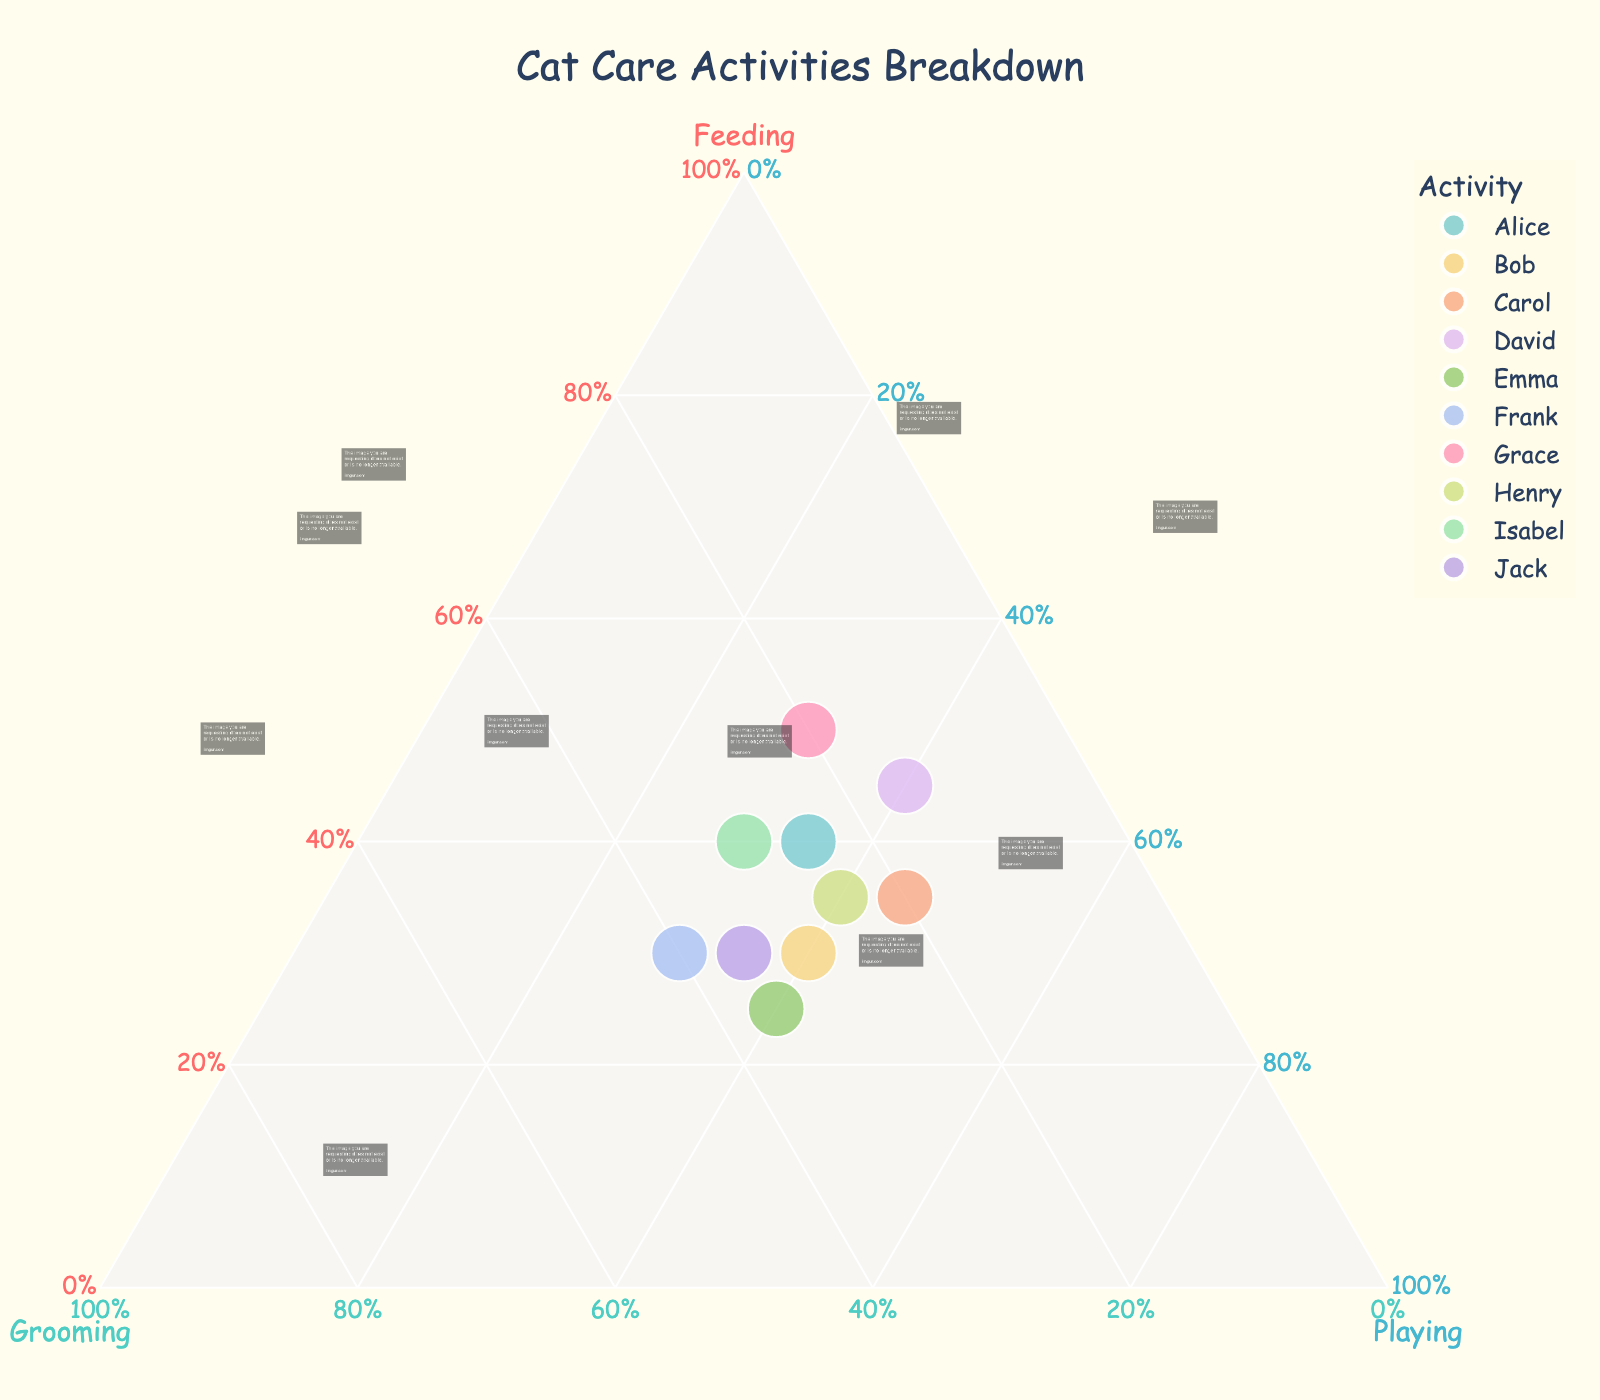What's the title of the plot? The title is the header text that summarizes the overall content of the plot. In this plot, the title reads "Cat Care Activities Breakdown".
Answer: Cat Care Activities Breakdown Which activity is represented by the red axis labeled on the plot? It can be seen that the title of the red axis is labeled "Feeding".
Answer: Feeding How many data points are in the plot? Each person (Alice, Bob, Carol, etc.) represents one data point on the plot. There are 10 such names, indicating 10 data points.
Answer: 10 Which cat owner spends the highest percentage of time feeding their cat? To determine this, check which data point is closest to the "Feeding" vertex. Based on the plot, Grace spends the highest percentage (50%) feeding her cat.
Answer: Grace Who spends an equal percentage of time between grooming and feeding? Check the data points where the grooming and feeding percentages are equal. From the plot, Bob has equal percentages (30%) for both grooming and feeding activities.
Answer: Bob Which two cat owners have the same pattern of time spent across feeding, grooming, and playing? Compare the positions of data points closely. Isabel and Jack both have similar balancing around 40% playing, indicating a similar pattern.
Answer: Isabel and Jack What is the average percentage of time spent playing among all cat owners? Add all the percentages for "Playing" and divide by the number of cat owners: (35+40+45+40+40+30+30+40+30+35) / 10 = 36.5%.
Answer: 36.5% If a new owner spends 50% of their time playing, how does it compare with others in the plot? Compare the new percentage for playing (50%) with the other values on the "Playing" axis. This owner would be spending more time playing than any of the current owners.
Answer: More than any current owner Which owner spends the lowest percentage of time grooming their cat? Find the point closest to the "Playing-Feeding" plane. David at 15% Grooming spends the least time on grooming.
Answer: David What's the main color scheme used in the plot? Check the various colors used. The color palette appears to be pastel shades to differentiate between the points.
Answer: Pastel colors 